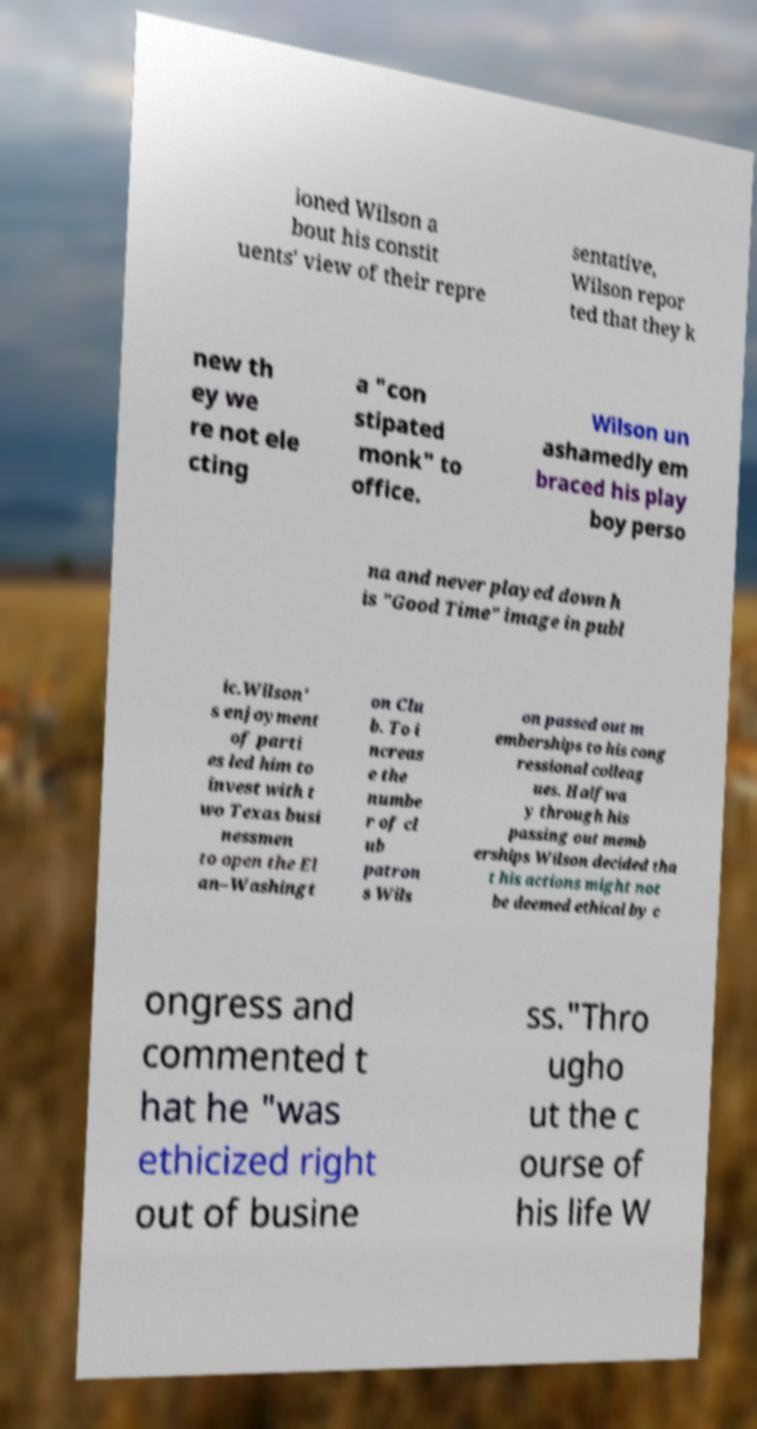Could you extract and type out the text from this image? ioned Wilson a bout his constit uents' view of their repre sentative, Wilson repor ted that they k new th ey we re not ele cting a "con stipated monk" to office. Wilson un ashamedly em braced his play boy perso na and never played down h is "Good Time" image in publ ic.Wilson' s enjoyment of parti es led him to invest with t wo Texas busi nessmen to open the El an–Washingt on Clu b. To i ncreas e the numbe r of cl ub patron s Wils on passed out m emberships to his cong ressional colleag ues. Halfwa y through his passing out memb erships Wilson decided tha t his actions might not be deemed ethical by c ongress and commented t hat he "was ethicized right out of busine ss."Thro ugho ut the c ourse of his life W 